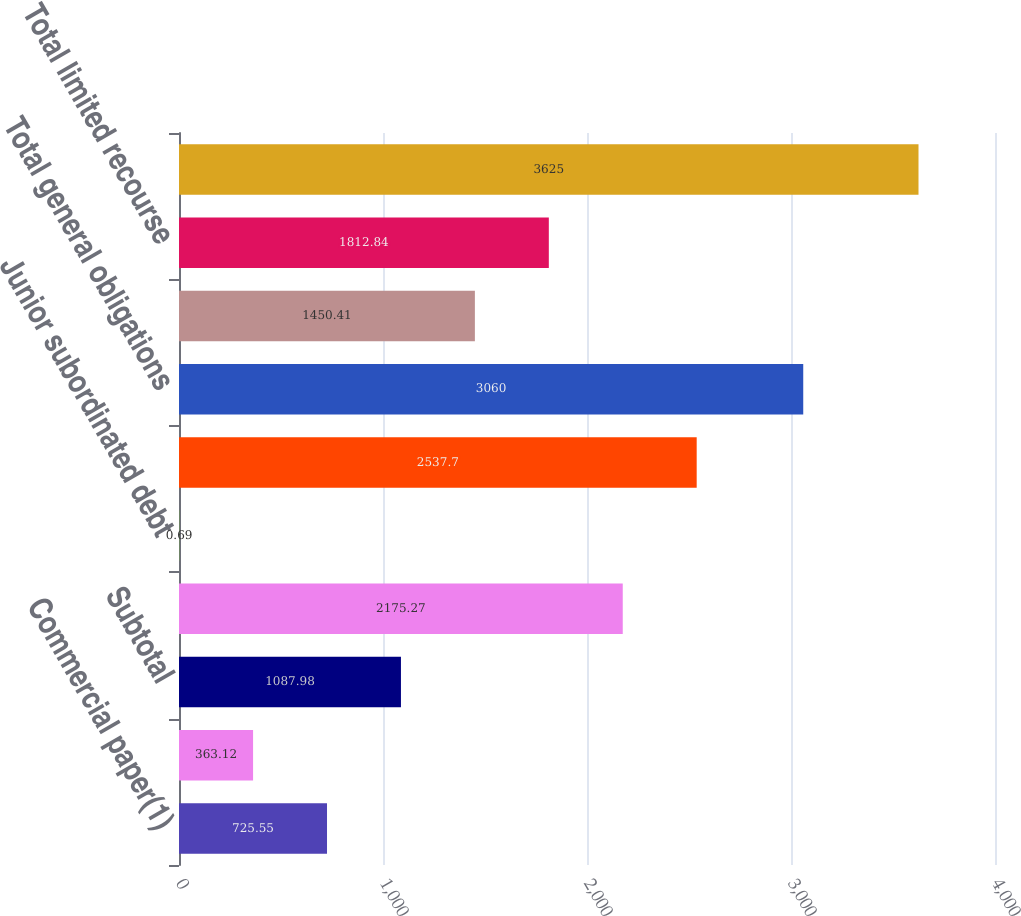Convert chart to OTSL. <chart><loc_0><loc_0><loc_500><loc_500><bar_chart><fcel>Commercial paper(1)<fcel>Current portion of long-term<fcel>Subtotal<fcel>Senior debt(3)<fcel>Junior subordinated debt<fcel>Surplus notes(4)<fcel>Total general obligations<fcel>Long-term debt<fcel>Total limited recourse<fcel>Total borrowings<nl><fcel>725.55<fcel>363.12<fcel>1087.98<fcel>2175.27<fcel>0.69<fcel>2537.7<fcel>3060<fcel>1450.41<fcel>1812.84<fcel>3625<nl></chart> 